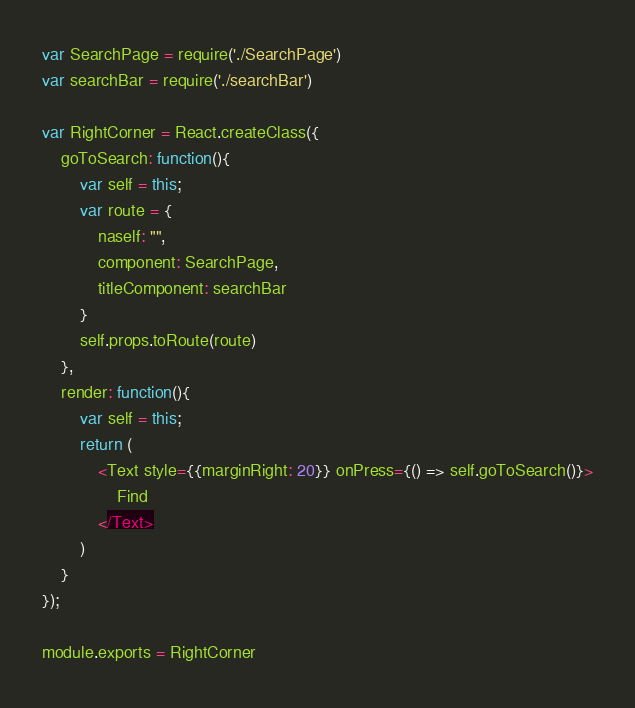<code> <loc_0><loc_0><loc_500><loc_500><_JavaScript_>var SearchPage = require('./SearchPage')
var searchBar = require('./searchBar')

var RightCorner = React.createClass({
    goToSearch: function(){
        var self = this;
        var route = {
            naself: "",
            component: SearchPage,
            titleComponent: searchBar
        }
        self.props.toRoute(route)
    },
    render: function(){
        var self = this;
        return (
            <Text style={{marginRight: 20}} onPress={() => self.goToSearch()}>
                Find
            </Text>
        )
    }
});

module.exports = RightCorner</code> 